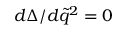<formula> <loc_0><loc_0><loc_500><loc_500>d \Delta / d \tilde { q } ^ { 2 } = 0</formula> 